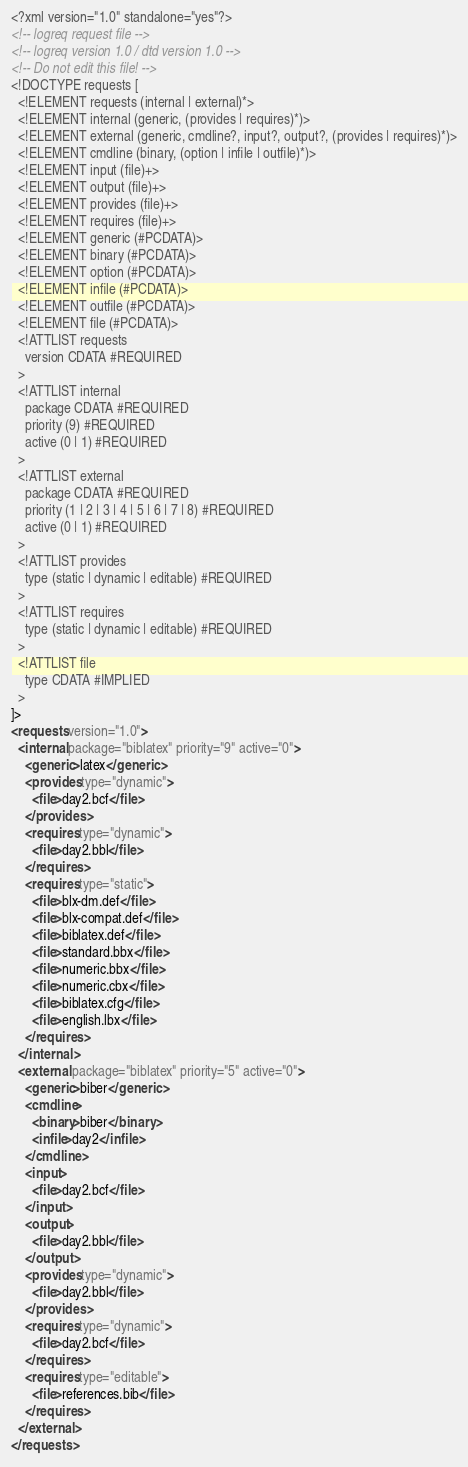<code> <loc_0><loc_0><loc_500><loc_500><_XML_><?xml version="1.0" standalone="yes"?>
<!-- logreq request file -->
<!-- logreq version 1.0 / dtd version 1.0 -->
<!-- Do not edit this file! -->
<!DOCTYPE requests [
  <!ELEMENT requests (internal | external)*>
  <!ELEMENT internal (generic, (provides | requires)*)>
  <!ELEMENT external (generic, cmdline?, input?, output?, (provides | requires)*)>
  <!ELEMENT cmdline (binary, (option | infile | outfile)*)>
  <!ELEMENT input (file)+>
  <!ELEMENT output (file)+>
  <!ELEMENT provides (file)+>
  <!ELEMENT requires (file)+>
  <!ELEMENT generic (#PCDATA)>
  <!ELEMENT binary (#PCDATA)>
  <!ELEMENT option (#PCDATA)>
  <!ELEMENT infile (#PCDATA)>
  <!ELEMENT outfile (#PCDATA)>
  <!ELEMENT file (#PCDATA)>
  <!ATTLIST requests
    version CDATA #REQUIRED
  >
  <!ATTLIST internal
    package CDATA #REQUIRED
    priority (9) #REQUIRED
    active (0 | 1) #REQUIRED
  >
  <!ATTLIST external
    package CDATA #REQUIRED
    priority (1 | 2 | 3 | 4 | 5 | 6 | 7 | 8) #REQUIRED
    active (0 | 1) #REQUIRED
  >
  <!ATTLIST provides
    type (static | dynamic | editable) #REQUIRED
  >
  <!ATTLIST requires
    type (static | dynamic | editable) #REQUIRED
  >
  <!ATTLIST file
    type CDATA #IMPLIED
  >
]>
<requests version="1.0">
  <internal package="biblatex" priority="9" active="0">
    <generic>latex</generic>
    <provides type="dynamic">
      <file>day2.bcf</file>
    </provides>
    <requires type="dynamic">
      <file>day2.bbl</file>
    </requires>
    <requires type="static">
      <file>blx-dm.def</file>
      <file>blx-compat.def</file>
      <file>biblatex.def</file>
      <file>standard.bbx</file>
      <file>numeric.bbx</file>
      <file>numeric.cbx</file>
      <file>biblatex.cfg</file>
      <file>english.lbx</file>
    </requires>
  </internal>
  <external package="biblatex" priority="5" active="0">
    <generic>biber</generic>
    <cmdline>
      <binary>biber</binary>
      <infile>day2</infile>
    </cmdline>
    <input>
      <file>day2.bcf</file>
    </input>
    <output>
      <file>day2.bbl</file>
    </output>
    <provides type="dynamic">
      <file>day2.bbl</file>
    </provides>
    <requires type="dynamic">
      <file>day2.bcf</file>
    </requires>
    <requires type="editable">
      <file>references.bib</file>
    </requires>
  </external>
</requests>
</code> 